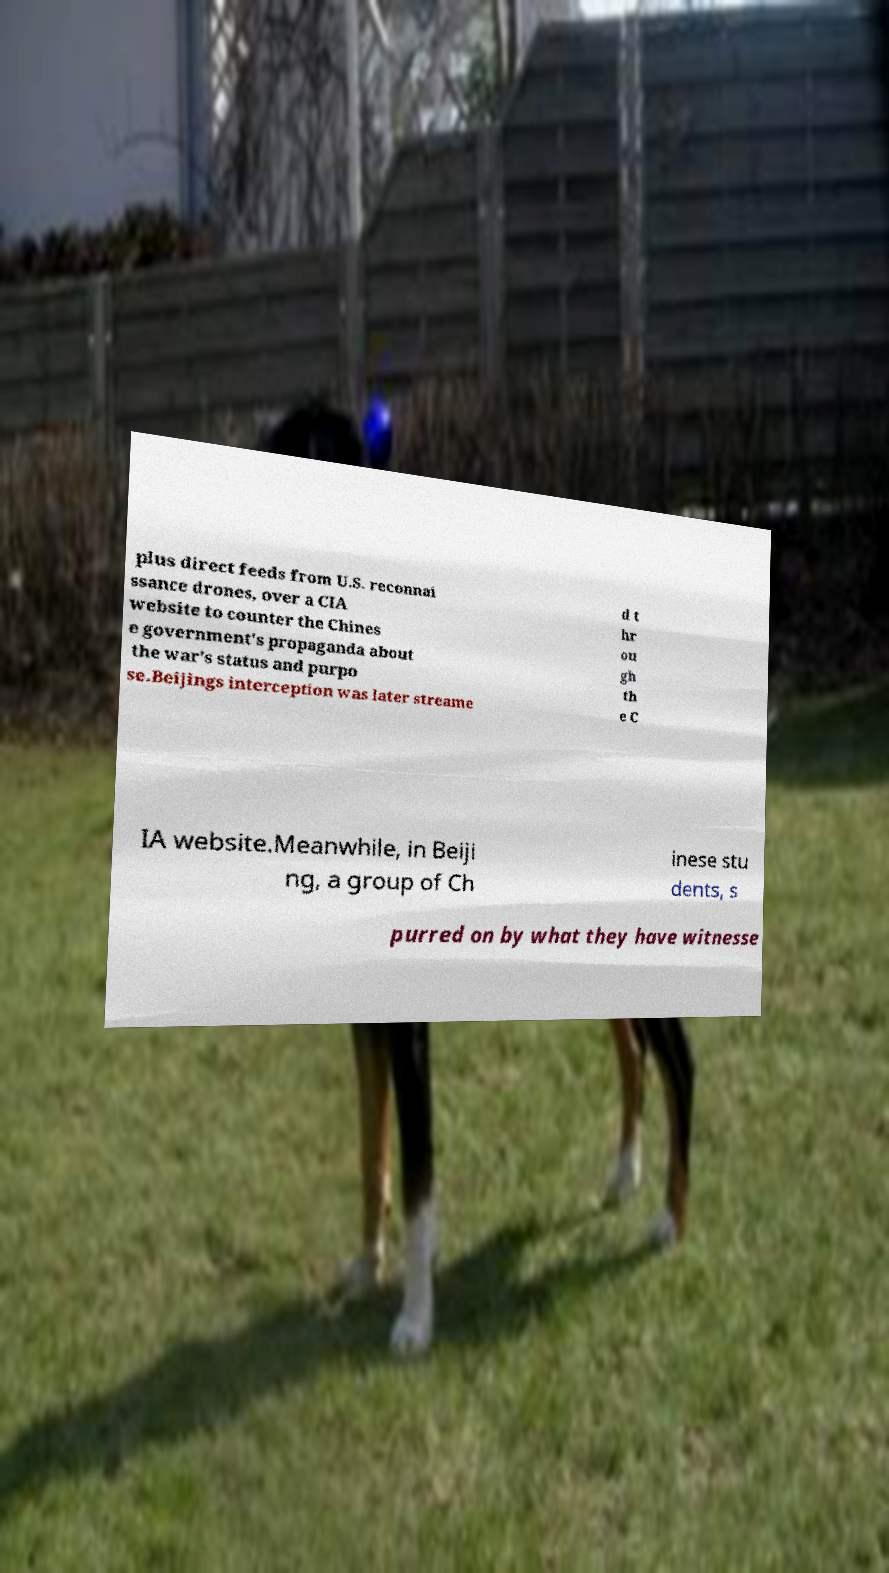For documentation purposes, I need the text within this image transcribed. Could you provide that? plus direct feeds from U.S. reconnai ssance drones, over a CIA website to counter the Chines e government's propaganda about the war's status and purpo se.Beijings interception was later streame d t hr ou gh th e C IA website.Meanwhile, in Beiji ng, a group of Ch inese stu dents, s purred on by what they have witnesse 